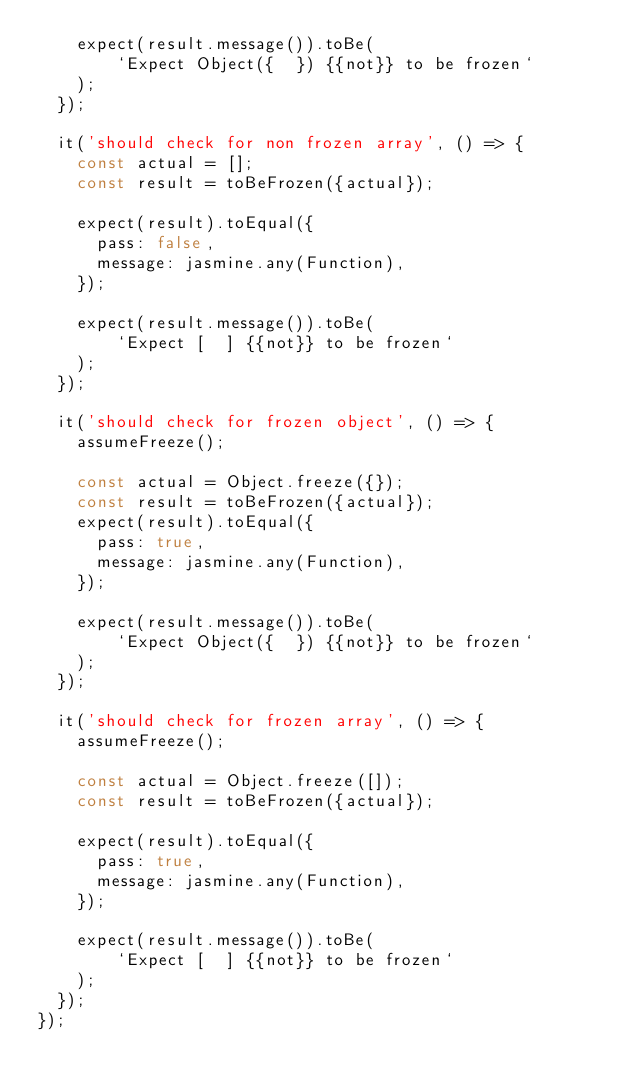<code> <loc_0><loc_0><loc_500><loc_500><_JavaScript_>    expect(result.message()).toBe(
        `Expect Object({  }) {{not}} to be frozen`
    );
  });

  it('should check for non frozen array', () => {
    const actual = [];
    const result = toBeFrozen({actual});

    expect(result).toEqual({
      pass: false,
      message: jasmine.any(Function),
    });

    expect(result.message()).toBe(
        `Expect [  ] {{not}} to be frozen`
    );
  });

  it('should check for frozen object', () => {
    assumeFreeze();

    const actual = Object.freeze({});
    const result = toBeFrozen({actual});
    expect(result).toEqual({
      pass: true,
      message: jasmine.any(Function),
    });

    expect(result.message()).toBe(
        `Expect Object({  }) {{not}} to be frozen`
    );
  });

  it('should check for frozen array', () => {
    assumeFreeze();

    const actual = Object.freeze([]);
    const result = toBeFrozen({actual});

    expect(result).toEqual({
      pass: true,
      message: jasmine.any(Function),
    });

    expect(result.message()).toBe(
        `Expect [  ] {{not}} to be frozen`
    );
  });
});
</code> 